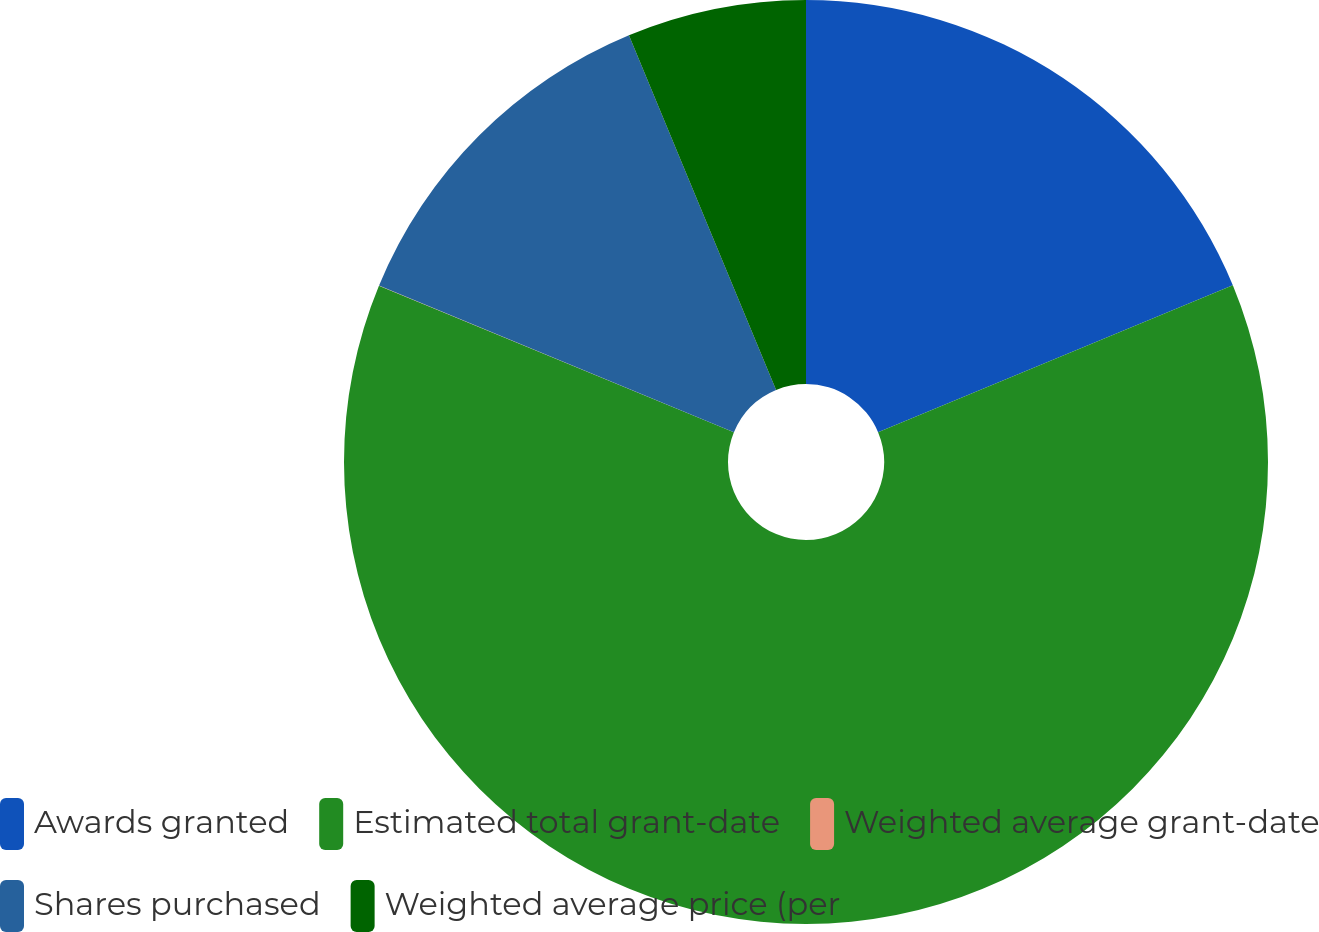Convert chart. <chart><loc_0><loc_0><loc_500><loc_500><pie_chart><fcel>Awards granted<fcel>Estimated total grant-date<fcel>Weighted average grant-date<fcel>Shares purchased<fcel>Weighted average price (per<nl><fcel>18.75%<fcel>62.48%<fcel>0.01%<fcel>12.5%<fcel>6.26%<nl></chart> 